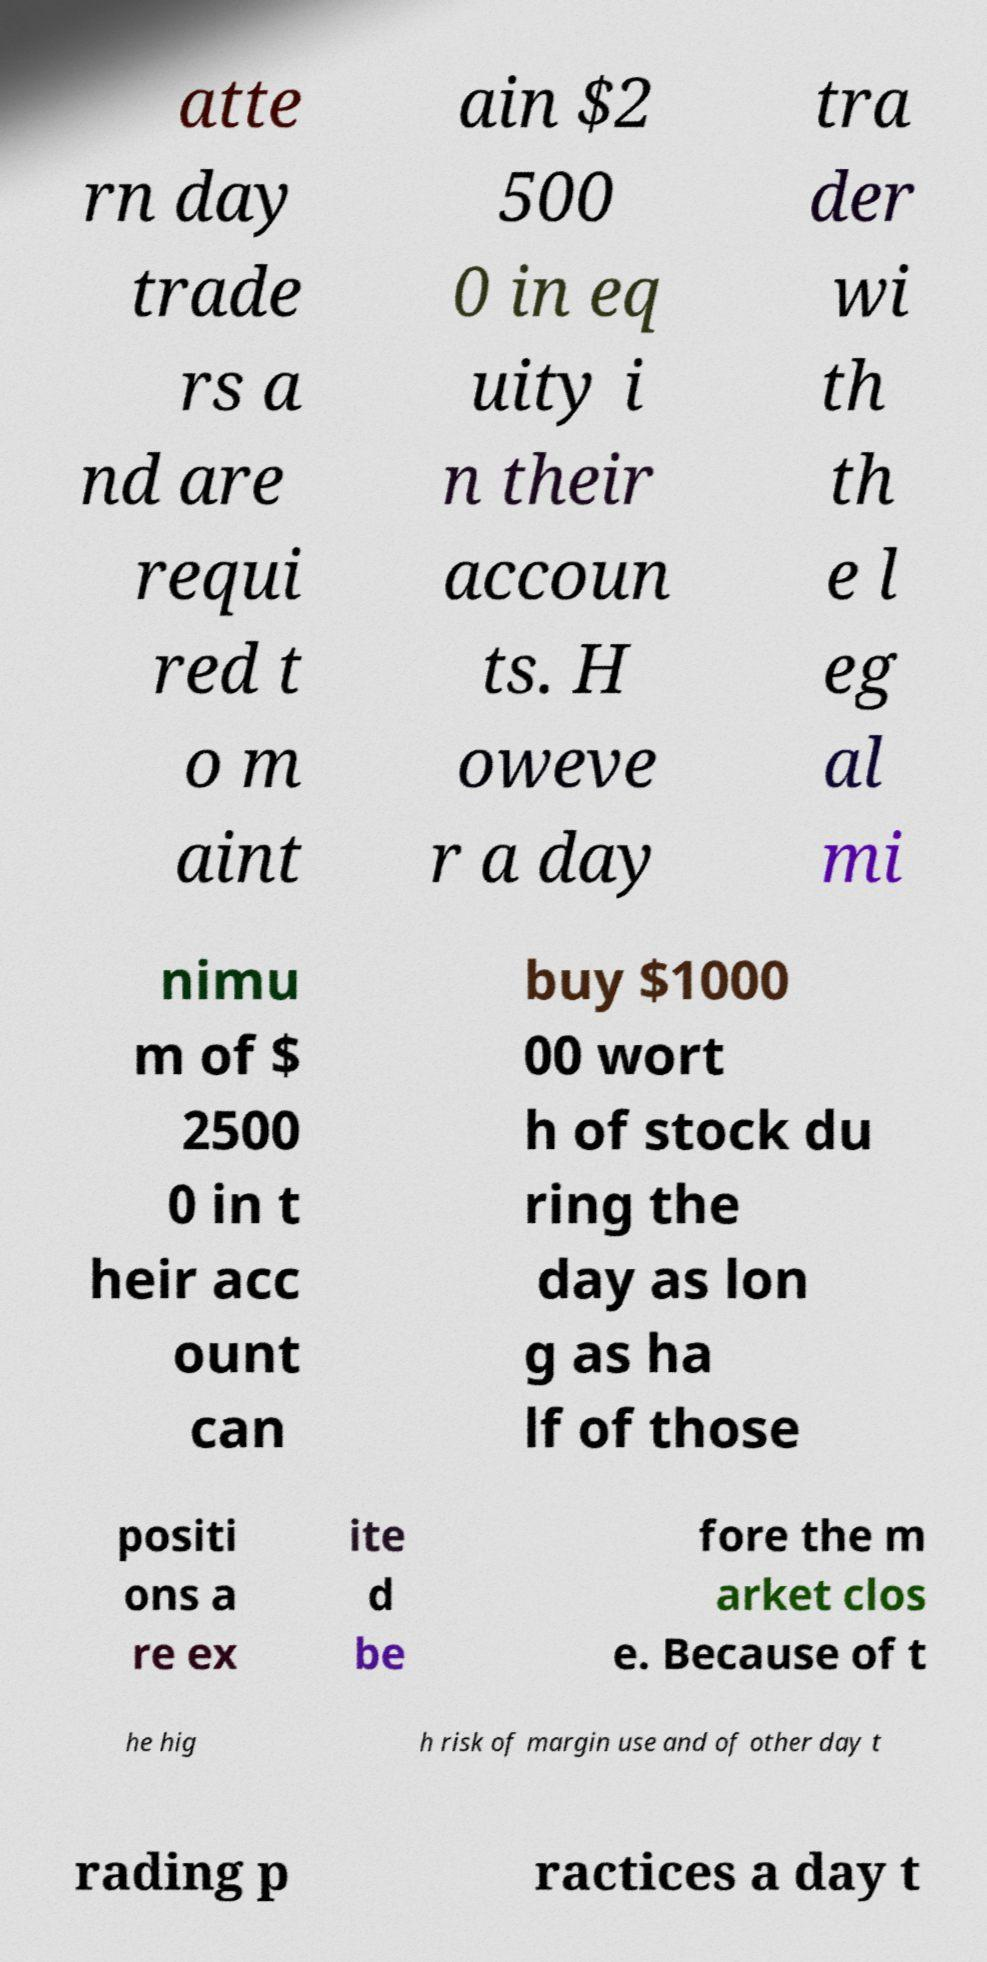Please identify and transcribe the text found in this image. atte rn day trade rs a nd are requi red t o m aint ain $2 500 0 in eq uity i n their accoun ts. H oweve r a day tra der wi th th e l eg al mi nimu m of $ 2500 0 in t heir acc ount can buy $1000 00 wort h of stock du ring the day as lon g as ha lf of those positi ons a re ex ite d be fore the m arket clos e. Because of t he hig h risk of margin use and of other day t rading p ractices a day t 